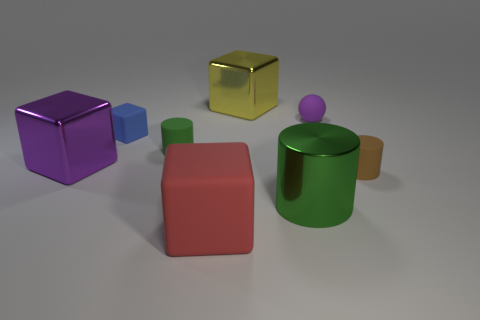What is the size of the purple rubber thing?
Provide a succinct answer. Small. What is the material of the red thing?
Ensure brevity in your answer.  Rubber. Do the purple matte sphere that is behind the blue matte cube and the blue object have the same size?
Ensure brevity in your answer.  Yes. What number of things are either big red rubber objects or tiny purple rubber spheres?
Offer a very short reply. 2. What is the shape of the large metal thing that is the same color as the tiny ball?
Your answer should be compact. Cube. What is the size of the rubber thing that is in front of the purple shiny cube and behind the red cube?
Keep it short and to the point. Small. How many red spheres are there?
Keep it short and to the point. 0. How many cylinders are red rubber objects or large brown objects?
Offer a very short reply. 0. There is a cylinder that is to the left of the metallic thing that is on the right side of the yellow cube; how many green rubber cylinders are in front of it?
Your response must be concise. 0. The matte sphere that is the same size as the green matte thing is what color?
Your answer should be compact. Purple. 